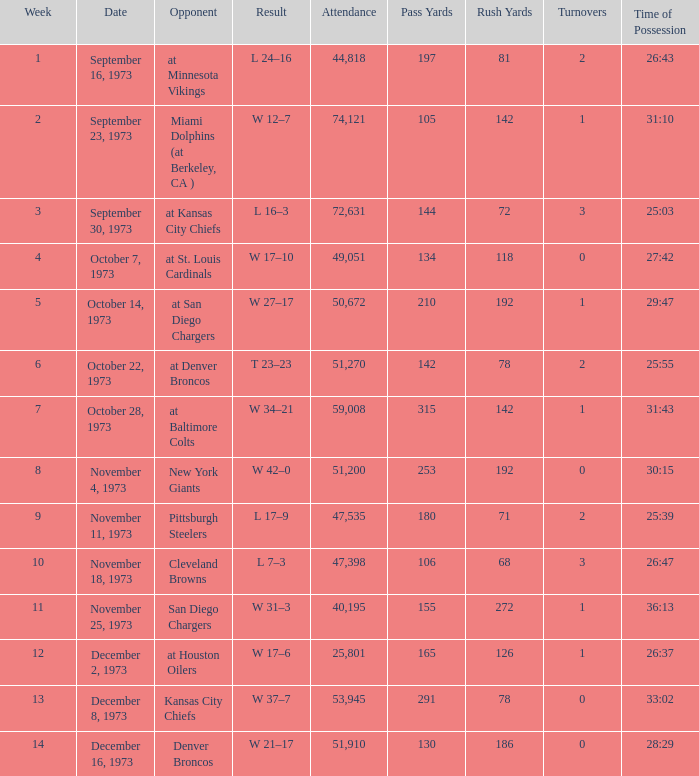What is the highest number in attendance against the game at Kansas City Chiefs? 72631.0. 